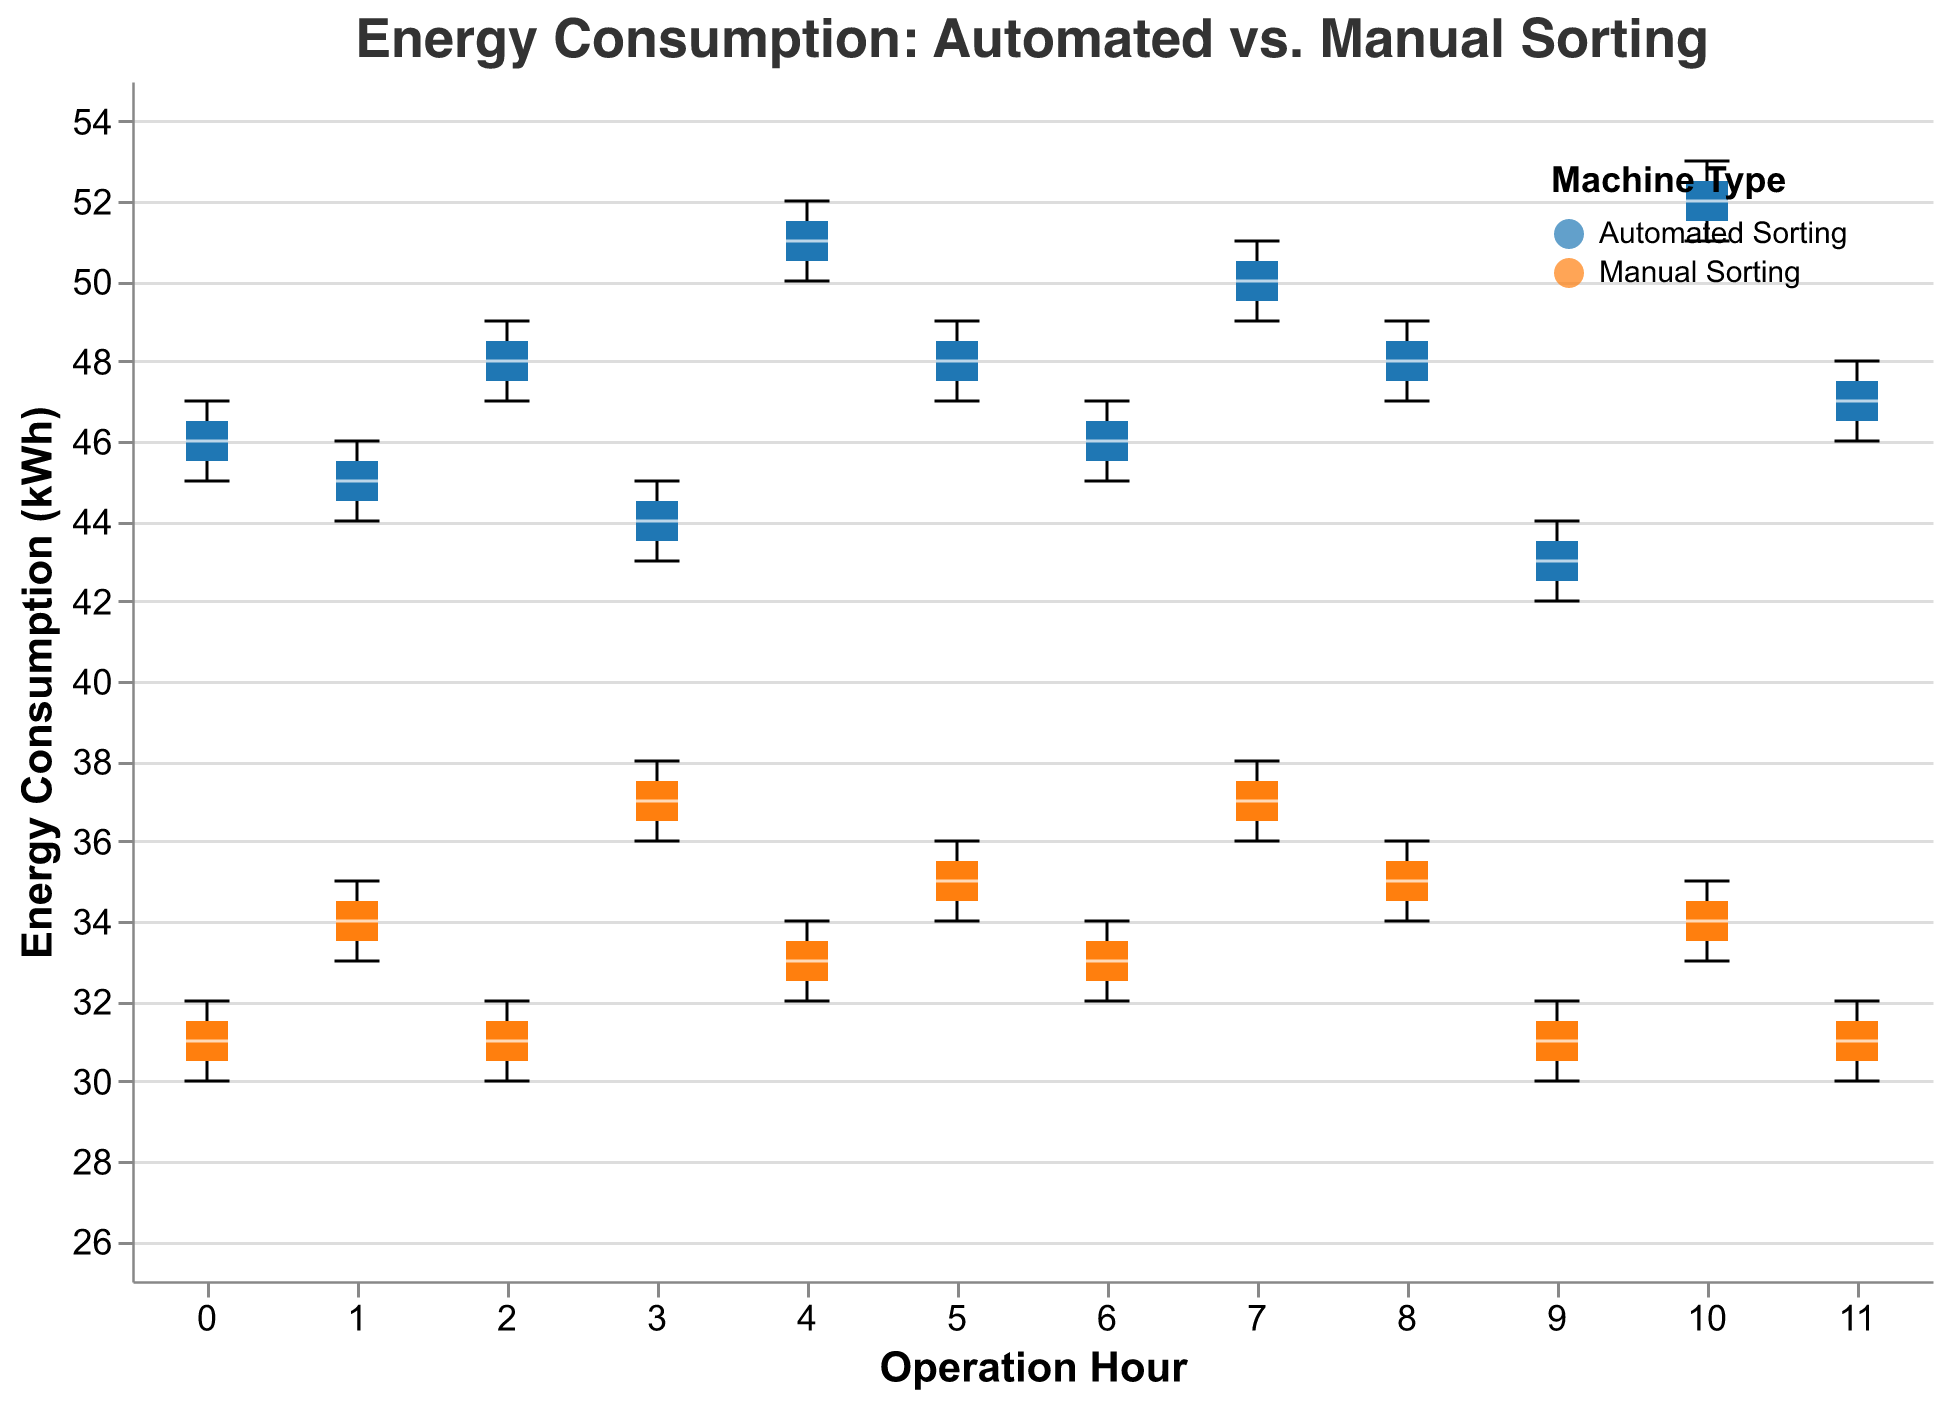How does the energy consumption of Automated Sorting machines vary across different hours? To determine how the energy consumption of Automated Sorting machines varies, observe the vertical spread of the blue box plots for each operation hour. The energy consumption varies from approximately 42 kWh to 53 kWh, with different medians and ranges at each hour.
Answer: Varies from 42 kWh to 53 kWh What is the median energy consumption for Manual Sorting at hour 3? To find the median energy consumption for Manual Sorting at hour 3, look at the orange box plot labeled "3" on the x-axis. The median is represented by the line inside the box.
Answer: 37 kWh Which machine type generally consumes more energy? Compare the overall height of the blue (Automated Sorting) and orange (Manual Sorting) box plots across all hours. Automated Sorting consistently has higher energy consumption.
Answer: Automated Sorting At which hour does Manual Sorting have the lowest median energy consumption? Locate the shortest median line within the orange box plots for each hour. The shortest is at hour 0.
Answer: Hour 0 What is the range of energy consumption for Automated Sorting at hour 2? The range of energy consumption for Automated Sorting at hour 2 is the difference between the maximum and minimum points in the blue box plot labeled "2" on the x-axis. The range is between 47 kWh and 49 kWh.
Answer: 47 kWh to 49 kWh How does the energy consumption at hour 7 compare between Automated and Manual Sorting? Compare the heights of the blue and orange box plots at hour 7. Automated Sorting consumes between 49 kWh and 51 kWh, while Manual Sorting consumes between 36 kWh and 38 kWh. Automated Sorting has higher consumption.
Answer: Automated Sorting is higher What are the quartile ranges for energy consumption of Manual Sorting at hour 11? The quartile ranges for Manual Sorting at hour 11 are represented by the boundaries of the box in the orange box plot labeled "11" on the x-axis. The interquartile range (middle 50%) falls between 30 kWh and 32 kWh.
Answer: 30 kWh to 32 kWh Is there any hour where Manual Sorting has a higher median energy consumption than Automated Sorting? Compare the median lines in the blue (Automated) and orange (Manual) box plots for all hours. At no hour does Manual Sorting have a higher median than Automated Sorting.
Answer: No Which hour shows the highest variability in energy consumption for Automated Sorting? The highest variability is indicated by the largest vertical spread of the blue box plots. Hour 10 shows the greatest variability, between 51 kWh and 53 kWh.
Answer: Hour 10 How does the energy consumption of Manual Sorting at hour 5 differ from its consumption at hour 8? Compare the heights of the orange box plots at hour 5 and hour 8. At hour 5, consumption ranges between 34 kWh and 36 kWh; at hour 8, it ranges between 34 kWh and 36 kWh. The ranges are quite similar.
Answer: Similar 